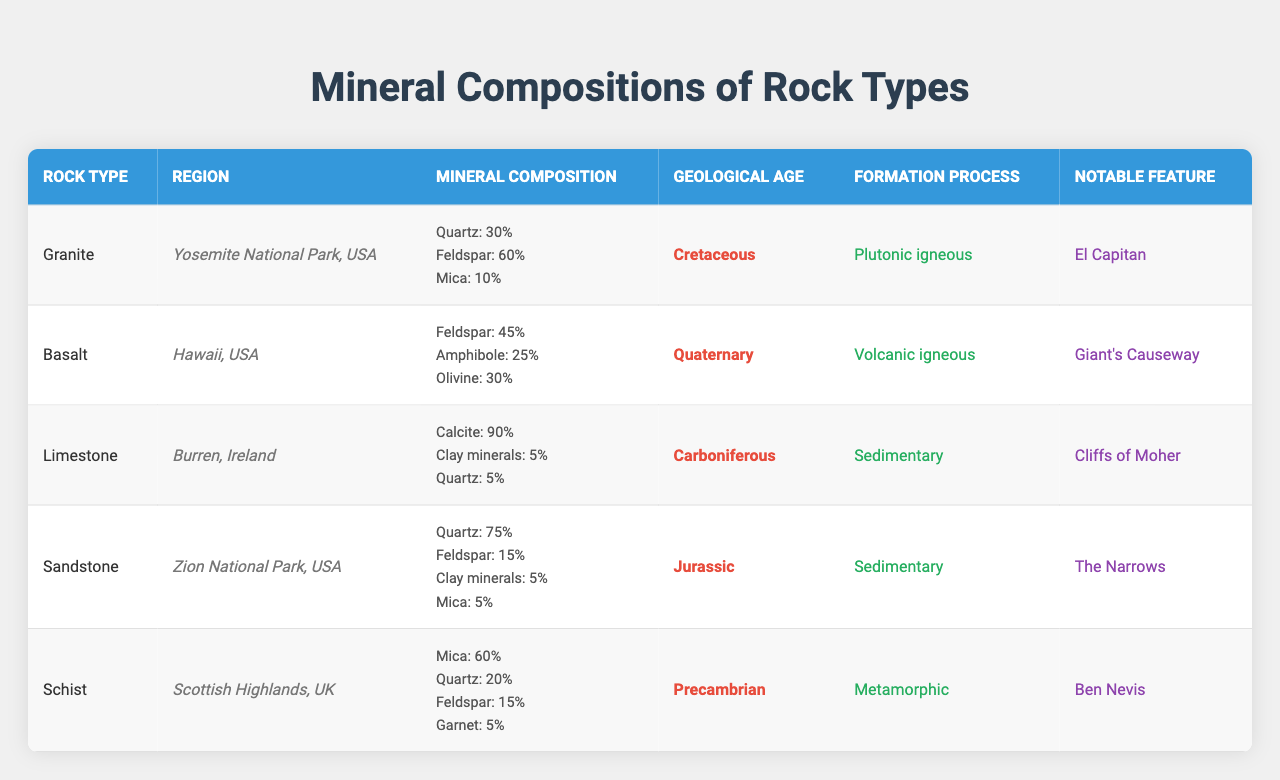What mineral makes up 90% of Limestone? The table indicates that Limestone comprises 90% Calcite, making it the predominant mineral in this rock type.
Answer: Calcite Which rock type has the highest percentage of Quartz? By examining the mineral composition, Sandstone has the highest Quartz content at 75%, compared to Granite at 30%, and Basalt which has none.
Answer: Sandstone How many minerals in Granite have a composition greater than 0%? The mineral composition of Granite shows that there are three minerals with a percentage greater than 0%: Quartz (30%), Feldspar (60%), and Mica (10).
Answer: 3 Is Basalt a sedimentary rock? Looking at the table, Basalt is categorized as volcanic igneous rock and not a sedimentary rock, making this statement false.
Answer: No What is the geological age of Schist? The table lists Schist's geological age as Precambrian, which directly provides the answer.
Answer: Precambrian How much percent of Feldspar is found in Sandstone? The mineral composition for Sandstone indicates that Feldspar makes up 15%, which is directly noted in the data.
Answer: 15% Which rock type has the notable feature 'El Capitan'? By referring to the notable features in the table, it can be identified that Granite is associated with El Capitan.
Answer: Granite Calculate the total percentage of Quartz across all rock types. The total percentage of Quartz is calculated by adding the contributions from each rock type: Granite (30%) + Basalt (0%) + Limestone (5%) + Sandstone (75%) + Schist (20%) = 130%.
Answer: 130% Which region is associated with the formation of Basalt? The table shows that Basalt is found in Hawaii, USA, which identifies this rock's region.
Answer: Hawaii, USA Which rock has the lowest mineral composition of Mica? Comparing the Mica content across the rock types indicates that Limestone and Basalt both have Mica at 0%, making them the lowest.
Answer: Limestone and Basalt What is the formation process of Limestone? According to the table, Limestone is formed through sedimentary processes, which is directly stated.
Answer: Sedimentary 